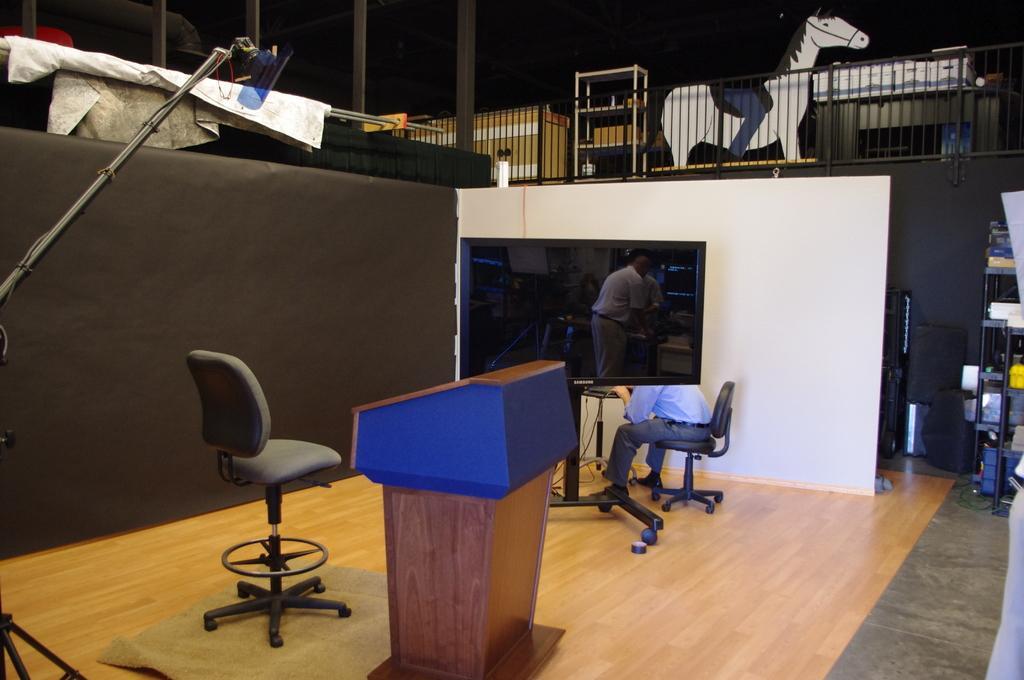Can you describe this image briefly? In this picture, there is a chair. There is a carpet on the floor. There is a wooden podium. There is a plasma TV and a person is sitting on the chair. There is a sheet. There is a rack on the top middle. There is a horse and a person is sitting on the horse. 